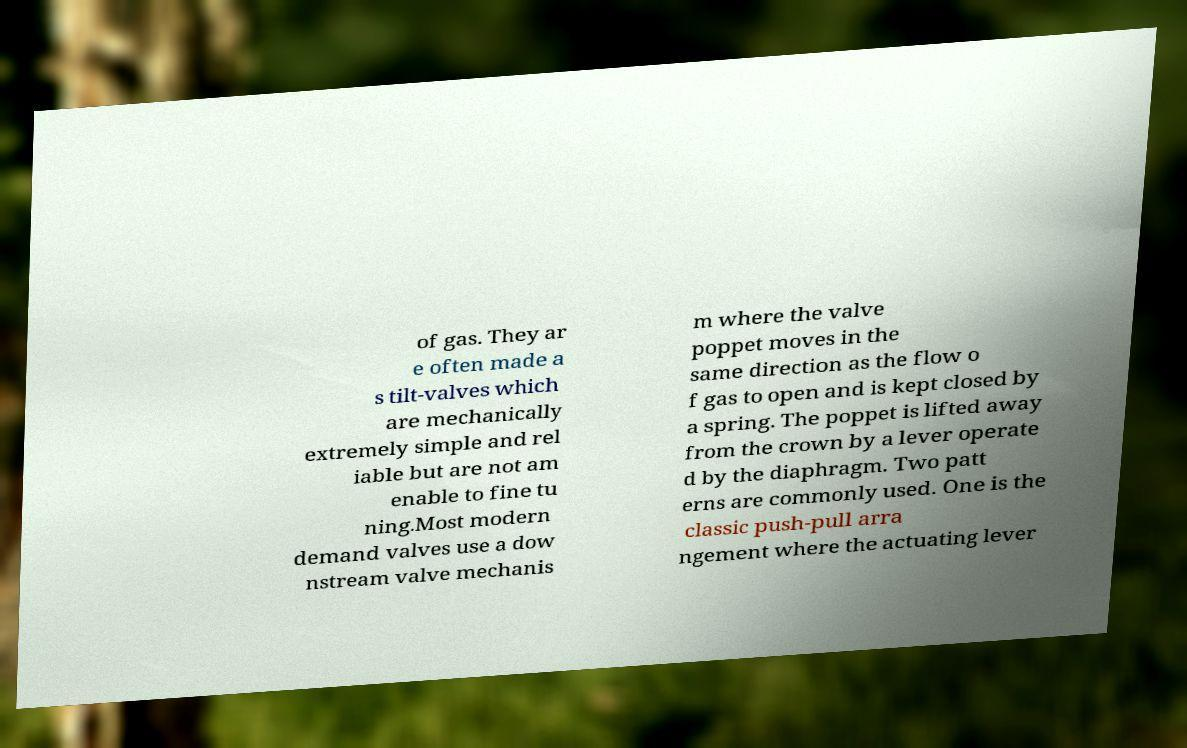Can you accurately transcribe the text from the provided image for me? of gas. They ar e often made a s tilt-valves which are mechanically extremely simple and rel iable but are not am enable to fine tu ning.Most modern demand valves use a dow nstream valve mechanis m where the valve poppet moves in the same direction as the flow o f gas to open and is kept closed by a spring. The poppet is lifted away from the crown by a lever operate d by the diaphragm. Two patt erns are commonly used. One is the classic push-pull arra ngement where the actuating lever 